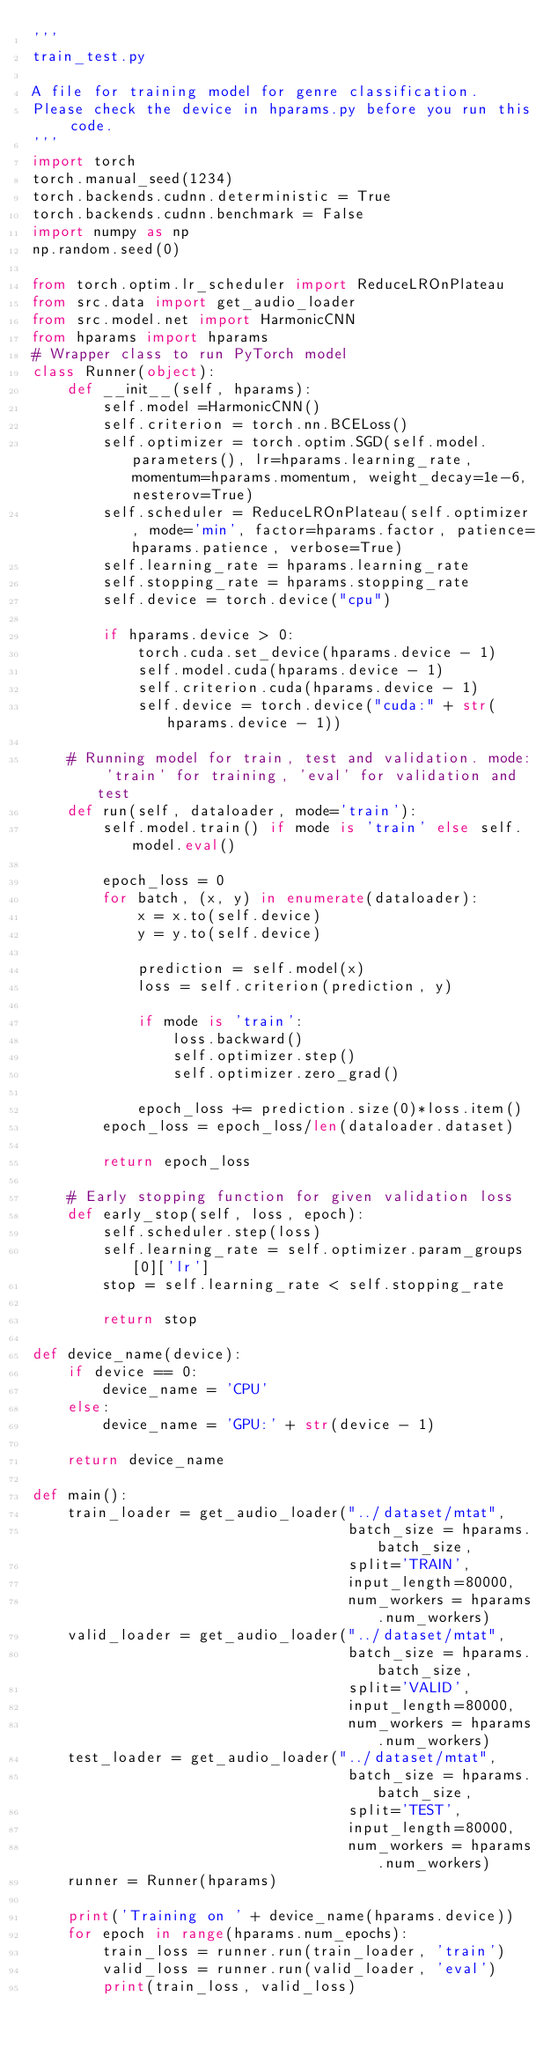Convert code to text. <code><loc_0><loc_0><loc_500><loc_500><_Python_>'''
train_test.py

A file for training model for genre classification.
Please check the device in hparams.py before you run this code.
'''
import torch
torch.manual_seed(1234)
torch.backends.cudnn.deterministic = True
torch.backends.cudnn.benchmark = False
import numpy as np
np.random.seed(0)

from torch.optim.lr_scheduler import ReduceLROnPlateau
from src.data import get_audio_loader
from src.model.net import HarmonicCNN
from hparams import hparams
# Wrapper class to run PyTorch model
class Runner(object):
    def __init__(self, hparams):
        self.model =HarmonicCNN()
        self.criterion = torch.nn.BCELoss()
        self.optimizer = torch.optim.SGD(self.model.parameters(), lr=hparams.learning_rate, momentum=hparams.momentum, weight_decay=1e-6, nesterov=True)
        self.scheduler = ReduceLROnPlateau(self.optimizer, mode='min', factor=hparams.factor, patience=hparams.patience, verbose=True)
        self.learning_rate = hparams.learning_rate
        self.stopping_rate = hparams.stopping_rate
        self.device = torch.device("cpu")

        if hparams.device > 0:
            torch.cuda.set_device(hparams.device - 1)
            self.model.cuda(hparams.device - 1)
            self.criterion.cuda(hparams.device - 1)
            self.device = torch.device("cuda:" + str(hparams.device - 1))

    # Running model for train, test and validation. mode: 'train' for training, 'eval' for validation and test
    def run(self, dataloader, mode='train'):
        self.model.train() if mode is 'train' else self.model.eval()

        epoch_loss = 0
        for batch, (x, y) in enumerate(dataloader):
            x = x.to(self.device)
            y = y.to(self.device)

            prediction = self.model(x)
            loss = self.criterion(prediction, y)
            
            if mode is 'train':
                loss.backward()
                self.optimizer.step()
                self.optimizer.zero_grad()

            epoch_loss += prediction.size(0)*loss.item()
        epoch_loss = epoch_loss/len(dataloader.dataset)

        return epoch_loss

    # Early stopping function for given validation loss
    def early_stop(self, loss, epoch):
        self.scheduler.step(loss)
        self.learning_rate = self.optimizer.param_groups[0]['lr']
        stop = self.learning_rate < self.stopping_rate

        return stop

def device_name(device):
    if device == 0:
        device_name = 'CPU'
    else:
        device_name = 'GPU:' + str(device - 1)

    return device_name

def main():
    train_loader = get_audio_loader("../dataset/mtat",
                                    batch_size = hparams.batch_size,
                                    split='TRAIN',
                                    input_length=80000,
                                    num_workers = hparams.num_workers)
    valid_loader = get_audio_loader("../dataset/mtat",
                                    batch_size = hparams.batch_size,
                                    split='VALID',
                                    input_length=80000,
                                    num_workers = hparams.num_workers)
    test_loader = get_audio_loader("../dataset/mtat",
                                    batch_size = hparams.batch_size,
                                    split='TEST',
                                    input_length=80000,
                                    num_workers = hparams.num_workers)
    runner = Runner(hparams)

    print('Training on ' + device_name(hparams.device))
    for epoch in range(hparams.num_epochs):
        train_loss = runner.run(train_loader, 'train')
        valid_loss = runner.run(valid_loader, 'eval')
        print(train_loss, valid_loss)
        </code> 